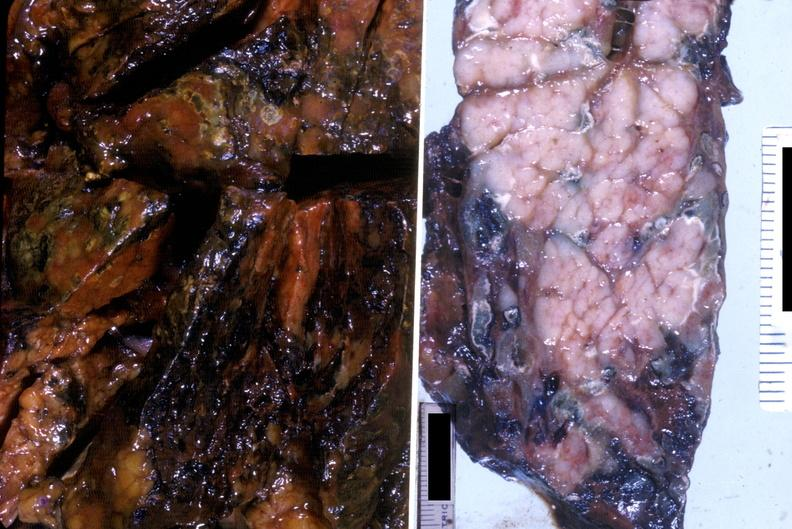does this image show acute hemorrhagic pancreatitis?
Answer the question using a single word or phrase. Yes 